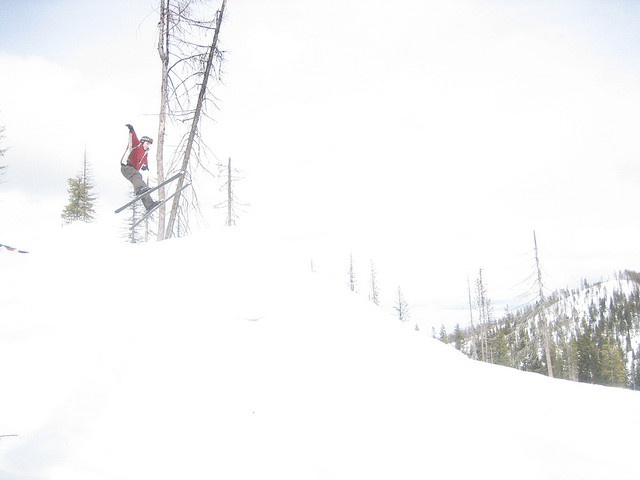Describe the objects in this image and their specific colors. I can see people in lightblue, darkgray, brown, lightgray, and gray tones and skis in lightblue, darkgray, and lightgray tones in this image. 